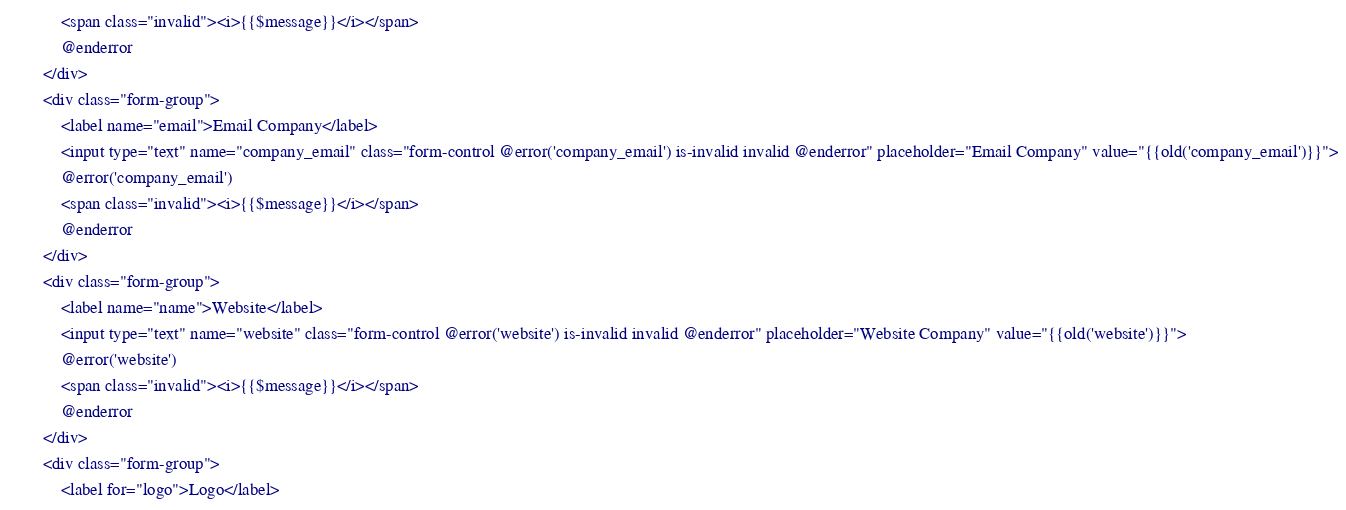<code> <loc_0><loc_0><loc_500><loc_500><_PHP_>            <span class="invalid"><i>{{$message}}</i></span>
            @enderror
        </div>
        <div class="form-group">
            <label name="email">Email Company</label>
            <input type="text" name="company_email" class="form-control @error('company_email') is-invalid invalid @enderror" placeholder="Email Company" value="{{old('company_email')}}">
            @error('company_email')
            <span class="invalid"><i>{{$message}}</i></span>
            @enderror
        </div>
        <div class="form-group">
            <label name="name">Website</label>
            <input type="text" name="website" class="form-control @error('website') is-invalid invalid @enderror" placeholder="Website Company" value="{{old('website')}}">
            @error('website')
            <span class="invalid"><i>{{$message}}</i></span>
            @enderror
        </div>
        <div class="form-group">
			<label for="logo">Logo</label></code> 